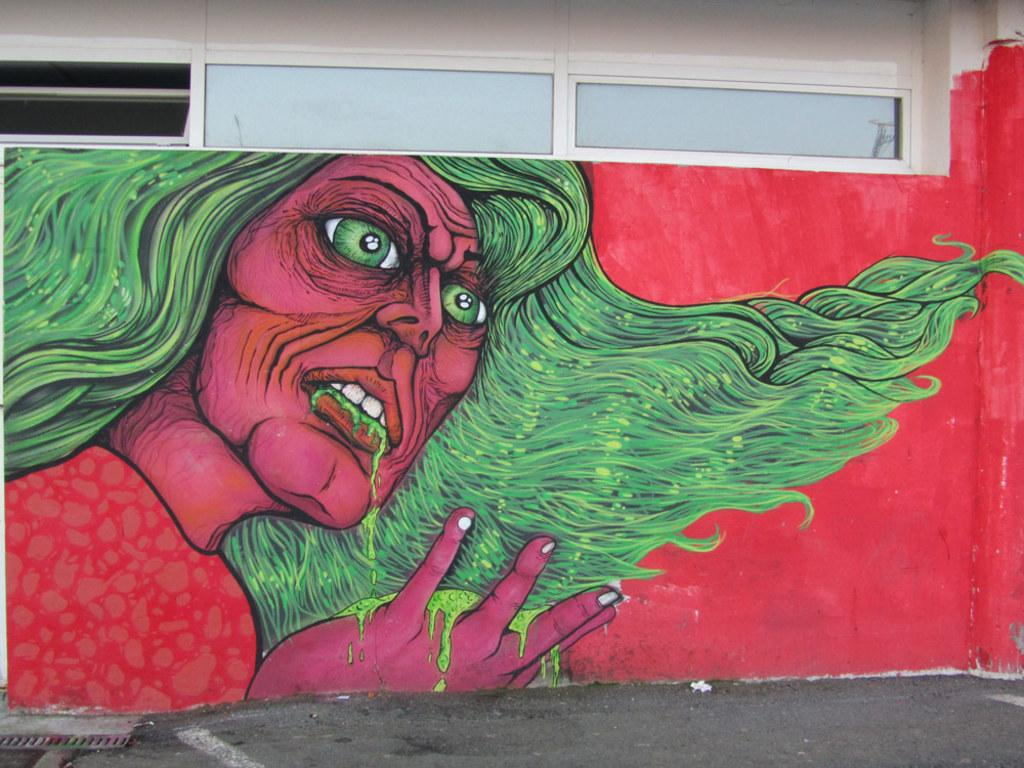What is depicted on the wall in the image? There is a painting on the wall in the image. What architectural features can be seen at the top of the image? There are windows and a wall at the top of the image. What surface is visible at the bottom of the image? There is a floor in the image. What object is located at the bottom of the image? There is an object at the bottom of the image. What type of wine is being served in the image? There is no wine present in the image. What is the income of the person depicted in the painting? The painting does not depict a person, and there is no information about income in the image. 